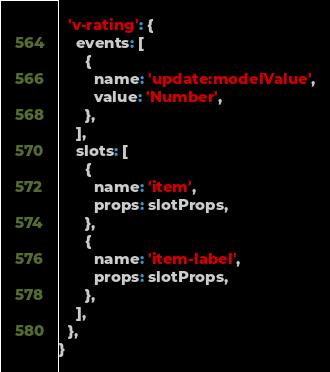Convert code to text. <code><loc_0><loc_0><loc_500><loc_500><_JavaScript_>  'v-rating': {
    events: [
      {
        name: 'update:modelValue',
        value: 'Number',
      },
    ],
    slots: [
      {
        name: 'item',
        props: slotProps,
      },
      {
        name: 'item-label',
        props: slotProps,
      },
    ],
  },
}
</code> 